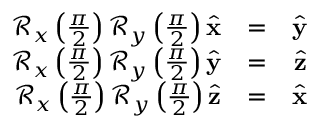<formula> <loc_0><loc_0><loc_500><loc_500>\begin{array} { r l r } { \mathcal { R } _ { x } \left ( \frac { \pi } { 2 } \right ) \mathcal { R } _ { y } \left ( \frac { \pi } { 2 } \right ) \hat { x } } & { = } & { \hat { y } } \\ { \mathcal { R } _ { x } \left ( \frac { \pi } { 2 } \right ) \mathcal { R } _ { y } \left ( \frac { \pi } { 2 } \right ) \hat { y } } & { = } & { \hat { z } } \\ { \mathcal { R } _ { x } \left ( \frac { \pi } { 2 } \right ) \mathcal { R } _ { y } \left ( \frac { \pi } { 2 } \right ) \hat { z } } & { = } & { \hat { x } } \end{array}</formula> 